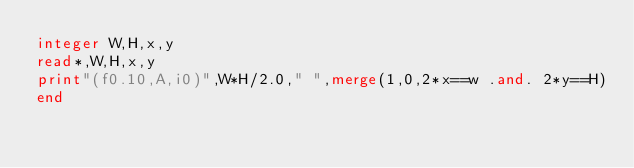Convert code to text. <code><loc_0><loc_0><loc_500><loc_500><_FORTRAN_>integer W,H,x,y
read*,W,H,x,y
print"(f0.10,A,i0)",W*H/2.0," ",merge(1,0,2*x==w .and. 2*y==H)
end</code> 